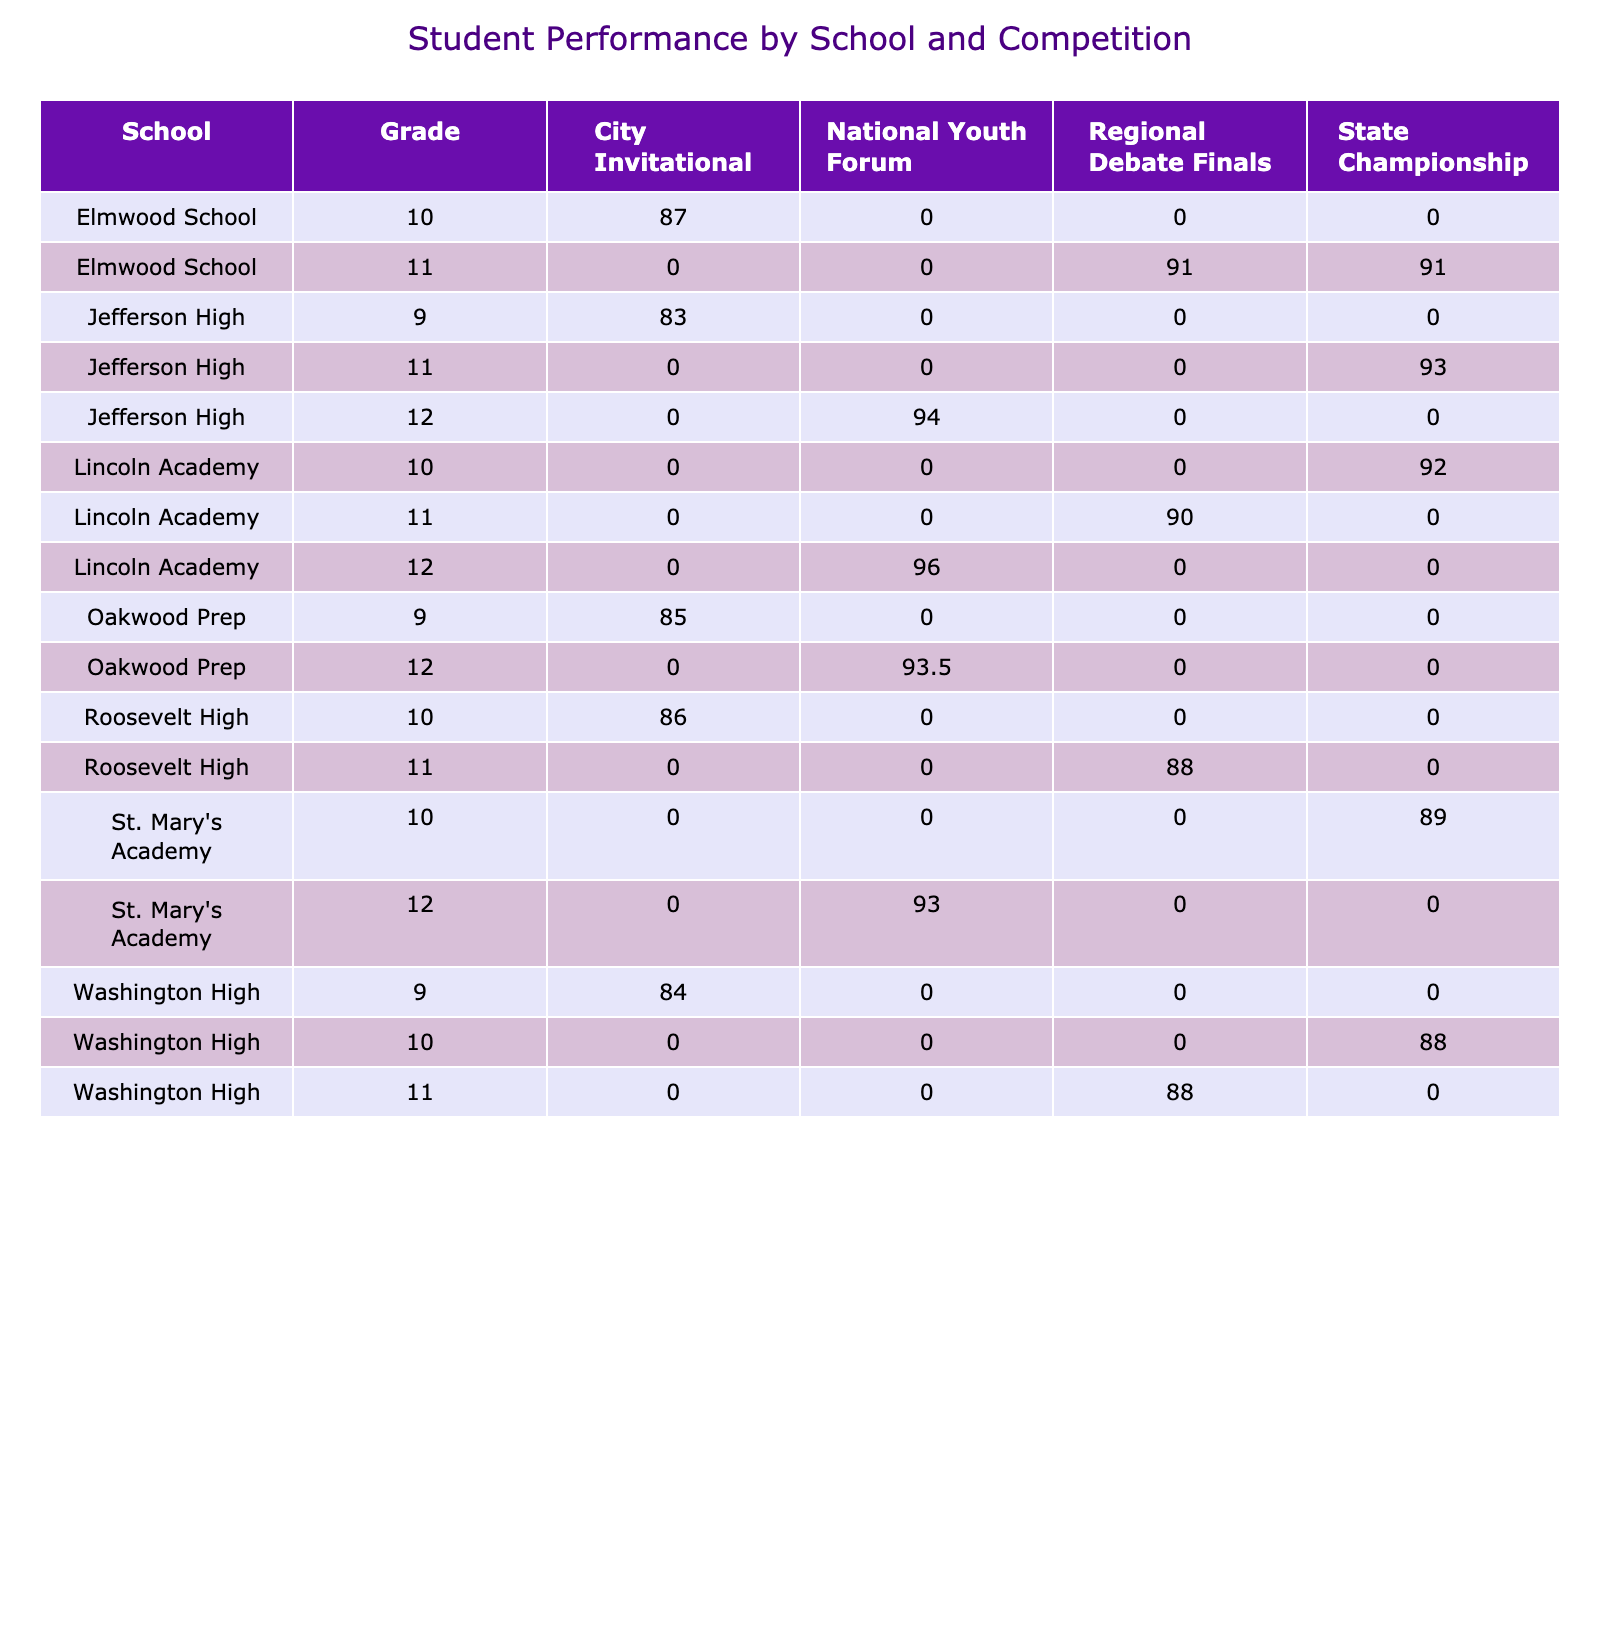What is the highest average score from Lincoln Academy? Looking at the scores from Lincoln Academy across different competitions, I see that for the State Championship, the average score is 89; for the Regional Debate Finals, it's 90, and the National Youth Forum features an average score of 96. The highest among these is 96.
Answer: 96 Which school had the lowest average score across the competitions? To find the lowest average score, I calculate the averages for each school. For example, Jefferson High has scores of 83 (City Invitational), 87 (City Invitational), and 93 (State Championship), which sums to 263 and averages to about 87.67. Meanwhile, each school's average score is calculated similarly, and it appears that Roosevelt High has the lowest average score of 88.
Answer: 88 Did any student score above 95 in the National Youth Forum? Reviewing the scores for the National Youth Forum, I see that Olivia Chen scored 95 and Amelia Martinez scored 96. Thus, there are students who scored above 95.
Answer: Yes What is the average score of students from Washington High? For Washington High, the scores from different competitions are 87 (Regional Debate Finals), 88 (State Championship), and 0 (missing data for National Youth Forum), which sums to 175. The average is 175 divided by the 3 competitions (including 0) amounting to around 58.33.
Answer: 58.33 How much higher is the average score of Oakwood Prep compared to Jefferson High? The scores for Oakwood Prep across competitions are 95 (National Youth Forum), 92 (National Youth Forum), and 0 (missing data for others), averaging 93.5. For Jefferson High, the average was found to be around 87.67. The difference is 93.5 - 87.67 = 5.83.
Answer: 5.83 What percentage of students scored above 90 in the City Invitational? The scores in the City Invitational are 83 (Noah Patel), 86 (Mason Lee), 85 (Lucas Taylor), and 84 (Benjamin Clark). Only Noah Patel has a score above 90. To calculate the percentage, there are 4 scores total, so the percentage is (0/4)*100 = 0%.
Answer: 0% Did any students from grade 9 score over 85? Looking at the scores for grade 9 students: Noah Patel scored 83, Lucas Taylor scored 85, and Benjamin Clark scored 84. None of the students from grade 9 scored over 85.
Answer: No Which competition had the highest overall average score? To find the highest overall average score, I calculate the averages of each competition. For example, the average scores for each competition are obtained by summing the scores per competition and dividing by total participants per competition. The highest average is found to be in the National Youth Forum, with an average score of 93.6.
Answer: National Youth Forum How many schools have a score below 90 in the Regional Debate Finals? In the Regional Debate Finals, the following scores are observed: 87 (Emma Thompson), 89 (Ava Williams), 90 (Isabella Nguyen), and 88 (Harper Anderson). Thus, two schools, Emma Thompson and Harper Anderson's schools, scored below 90.
Answer: 2 